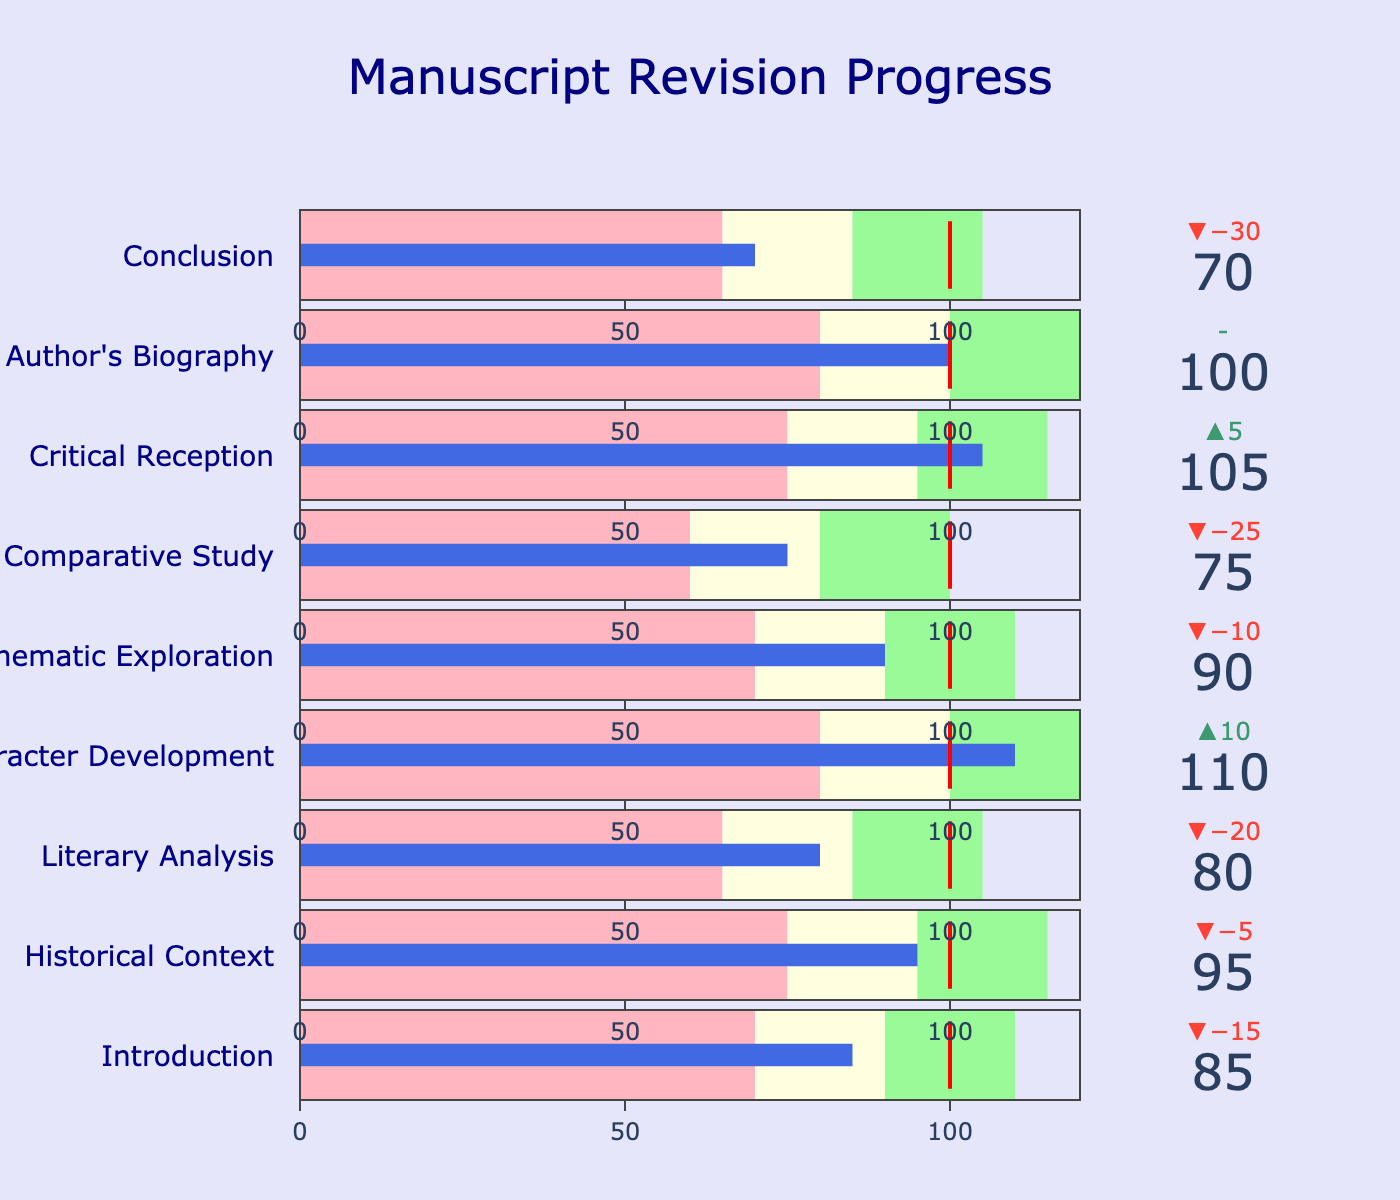What's the title of the plot? The title of the plot is displayed at the top of the figure.
Answer: Manuscript Revision Progress How many chapters are shown in the chart? Count the number of bullets representing different chapters in the chart.
Answer: 9 What is the actual revision progress for the chapter "Character Development"? Look at the value marked "Character Development" in the figure.
Answer: 110 Which chapter exceeds the target revision by the most? Compare the actual values with the target values for each chapter and determine which has the largest positive difference.
Answer: Character Development Which chapters' actual revision progress falls into the "Satisfactory" range? Check each bullet chart to see if the actual value falls within the "Satisfactory" range for each chapter.
Answer: Historical Context, Thematic Exploration, Author's Biography What is the difference between the target and actual revision progress for "Conclusion"? Subtract the actual revision value from the target value for "Conclusion".
Answer: 30 (100 - 70) What color represents the "Warning" range in the charts? Identify the color used to depict the "Warning" range in the background of the bullets.
Answer: Light pink How many chapters have exceeded their "Excellent" revision progress goals? Count the chapters where the actual progress value surpasses the "Excellent" range.
Answer: None Between which ranges does the value for "Critical Reception" fall, and what does this signify? Identify the actual value for "Critical Reception" and see which range it falls into on its bullet chart.
Answer: Between 95 and 115; it signifies satisfactory progress 